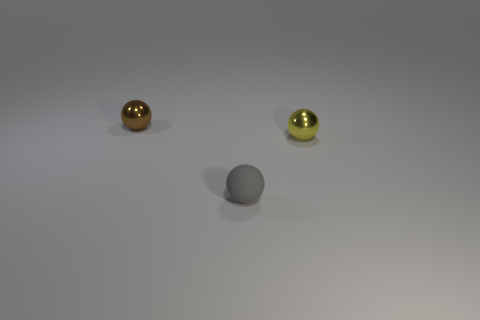Is the number of gray rubber spheres in front of the small gray ball less than the number of big purple metal cubes?
Make the answer very short. No. How many cyan matte balls are there?
Make the answer very short. 0. What number of small brown spheres are made of the same material as the small gray sphere?
Offer a very short reply. 0. How many things are either small metal objects right of the small brown object or big cyan rubber cylinders?
Provide a short and direct response. 1. Is the number of small shiny spheres in front of the small gray matte ball less than the number of tiny gray matte things that are in front of the yellow metallic ball?
Your answer should be very brief. Yes. There is a gray object; are there any balls behind it?
Make the answer very short. Yes. What number of things are metallic objects that are left of the matte ball or shiny things that are in front of the tiny brown thing?
Offer a terse response. 2. What number of other matte balls have the same color as the tiny matte sphere?
Ensure brevity in your answer.  0. There is another tiny metal object that is the same shape as the yellow thing; what is its color?
Ensure brevity in your answer.  Brown. The object that is right of the brown object and behind the small gray matte thing has what shape?
Your response must be concise. Sphere. 